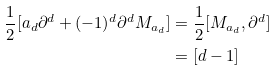Convert formula to latex. <formula><loc_0><loc_0><loc_500><loc_500>\frac { 1 } { 2 } [ a _ { d } \partial ^ { d } + ( - 1 ) ^ { d } \partial ^ { d } M _ { a _ { d } } ] & = \frac { 1 } { 2 } [ M _ { a _ { d } } , \partial ^ { d } ] \\ & = [ d - 1 ]</formula> 